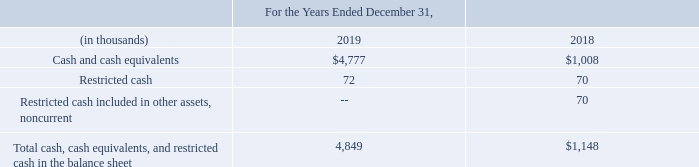Cash and Cash Equivalents
Cash and cash equivalents consist of cash, checking accounts, money market accounts and temporary investments with maturities of three months or less when purchased. As of December 31, 2019 and 2018, the Company had no cash equivalents.
Restricted Cash
In connection with certain transactions, the Company may be required to deposit assets, including cash or investment shares, in escrow accounts. The assets held in escrow are subject to various contingencies that may exist with respect to such transactions. Upon resolution of those contingencies or the expiration of the escrow period, some or all the escrow amounts may be used and the balance released to the Company. As of December 31, 2019 and 2018, the Company had $72,000 and $140,000, respectively, deposited in escrow as restricted cash for the Shoom acquisition, of which any amounts not subject to claims shall be released to the pre-acquisition stockholders of Shoom pro-rata on the next anniversary dates of the closing date of the Shoom acquisition. As of December 31, 2019 and 2018, $72,000 and $70,000, respectively, was current and included in Prepaid Assets and Other Current Assets on the consolidated balance sheets. As of December 31, 2019 and 2018, $0 and $70,000 was non-current and included in Other Assets on the consolidated balance sheet.
The following table provides a reconciliation of cash, cash equivalents and restricted cash reported in the balance sheets that sum to the total of the same amounts show in the statement of cash flows.
What does cash and cash equivalents consist of? Cash, checking accounts, money market accounts and temporary investments with maturities of three months or less when purchased. What was the amount in escrow as restricted cash at 2019 and 2018 respectively? 72,000, 140,000. What was the Cash and cash equivalents in 2019 and 2018 respectively?
Answer scale should be: thousand. $4,777, $1,008. In which year  was Restricted cash included in other assets, noncurrent less than 70 thousands? Locate and analyze restricted cash included in other assets, noncurrent in row 5
answer: 2019. What is the average Restricted cash for 2018 and 2019?
Answer scale should be: thousand. (72 + 70) / 2
Answer: 71. What was the change in the Cash and cash equivalents from 2018 to 2019?
Answer scale should be: thousand. 4,777 - 1,008
Answer: 3769. 